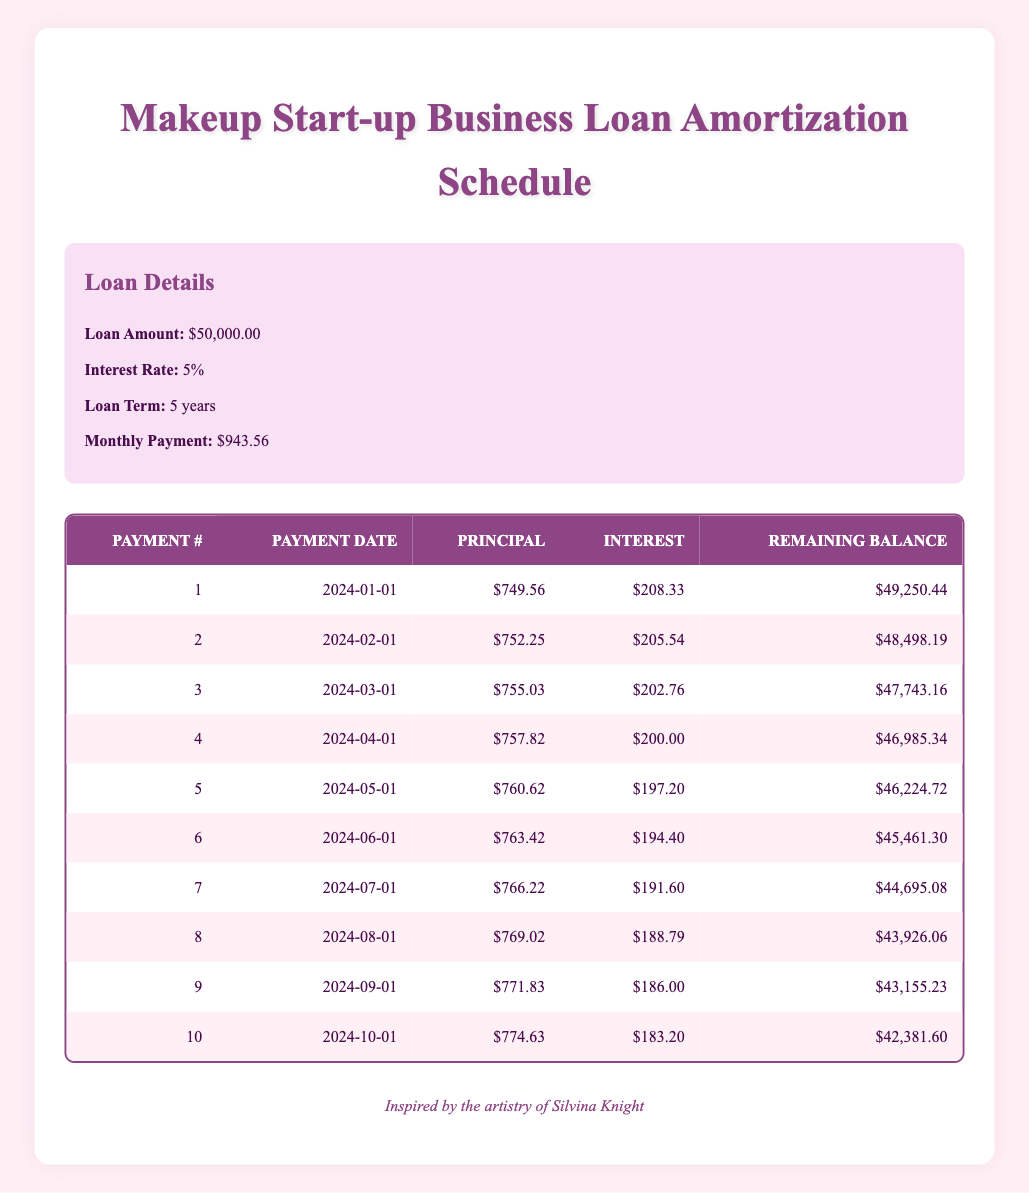What is the total loan amount? The loan amount is explicitly mentioned in the loan details section as 50,000.00.
Answer: 50,000.00 How much is the monthly payment for the loan? The monthly payment is listed in the loan details as 943.56.
Answer: 943.56 What is the principal payment for the first month? The principal payment for the first month is located in the first row of the payment schedule and is 749.56.
Answer: 749.56 What is the total interest paid in the first three months? The interest payments for the first three months are 208.33, 205.54, and 202.76. Adding these values together gives 208.33 + 205.54 + 202.76 = 616.63.
Answer: 616.63 Is the interest payment for the second month lower than the first month? The interest payment for the first month is 208.33, and for the second month, it is 205.54, thus 205.54 is lower than 208.33.
Answer: Yes What is the remaining balance after the sixth payment? The remaining balance after the sixth payment can be found in the payment schedule under the sixth payment row, which lists it as 45,461.30.
Answer: 45,461.30 What is the total principal paid after the first five payments? The principal payments for the first five months are 749.56, 752.25, 755.03, 757.82, and 760.62. Summing them gives 749.56 + 752.25 + 755.03 + 757.82 + 760.62 = 3775.28.
Answer: 3775.28 What is the difference between the interest payment in the fourth month and the interest payment in the third month? The interest payment in the fourth month is 200.00, and in the third month is 202.76. The difference can be calculated as 202.76 - 200.00 = 2.76.
Answer: 2.76 How many payments are made until the remaining balance goes below 45,000? By observing the table, the remaining balance falls below 45,000 after the seventh payment, which means 7 payments are needed to reach that point.
Answer: 7 